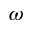Convert formula to latex. <formula><loc_0><loc_0><loc_500><loc_500>\omega</formula> 